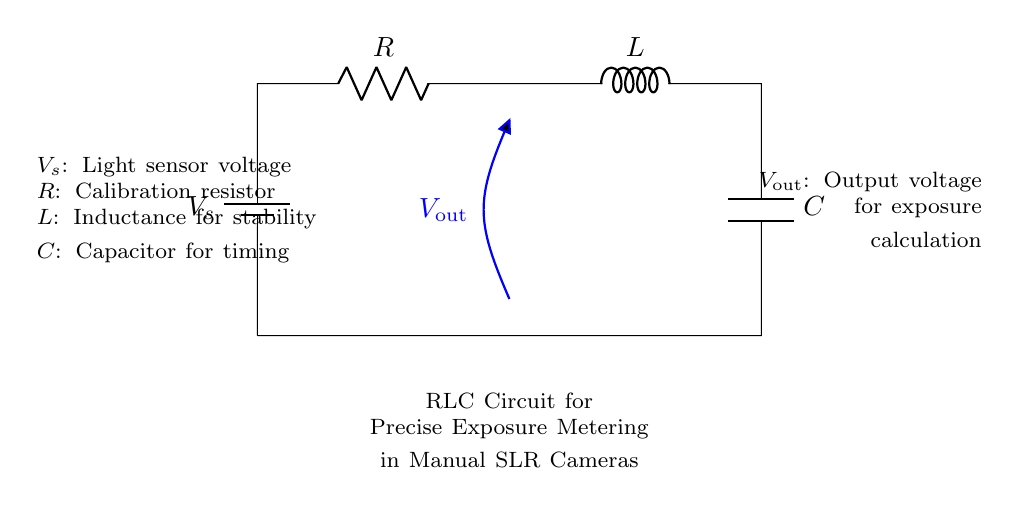What is the function of R in this circuit? The resistor (R) functions as a calibration component, affecting the current flow and overall resistance in the circuit, which helps to fine-tune the exposure readings.
Answer: Calibration resistor What is the role of L in this circuit? The inductor (L) provides stability to the circuit by smoothing out fluctuations in current, which can help in maintaining a consistent voltage output for exposure metering.
Answer: Stability What does V_s represent? V_s represents the voltage sourced from the light sensor, which is crucial for determining the exposure level based on light intensity in the scene being photographed.
Answer: Light sensor voltage How is V_out determined in the circuit? V_out is the output voltage for exposure calculation, derived from the interplay of the resistance, inductance, and capacitance in response to V_s, affecting the circuit's transient response.
Answer: Output voltage What is the purpose of C in the circuit? The capacitor (C) stores charge and affects the timing aspect of the exposure meter, smoothing the output for a more stable reading over time when compensating for changes in light.
Answer: Timing Which component stabilizes the voltage output? The inductor (L) stabilizes the voltage output by resisting changes in current, ensuring that voltage remains consistent despite fluctuations in input or circuit dynamics.
Answer: Inductor What type of circuit is this? This is an RLC circuit, specifically designed for precise exposure metering in manual SLR cameras, combining resistor, inductor, and capacitor for accuracy.
Answer: RLC circuit 